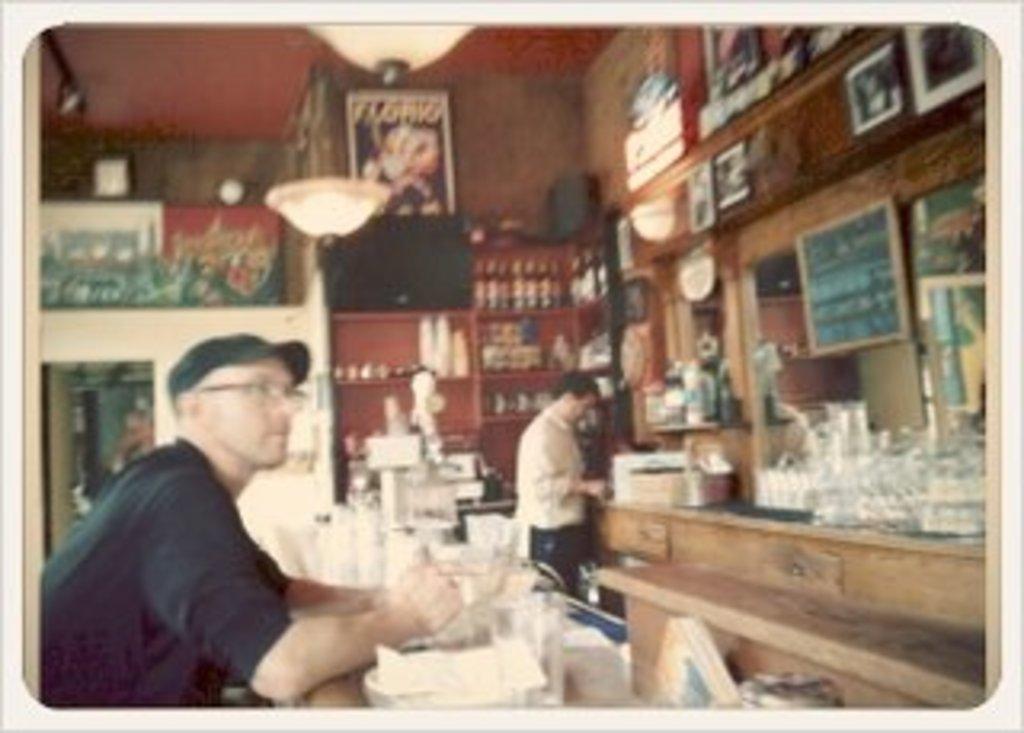Describe this image in one or two sentences. To the left corner of the image there is a man with black dress and black cap is sitting. In front of him there is a table with a few items on it. To the right side corner of the image there is a table with a few items on it. In front of the table there is a man standing. And to wall there are many frames. And to the top of the image there are lamps. 